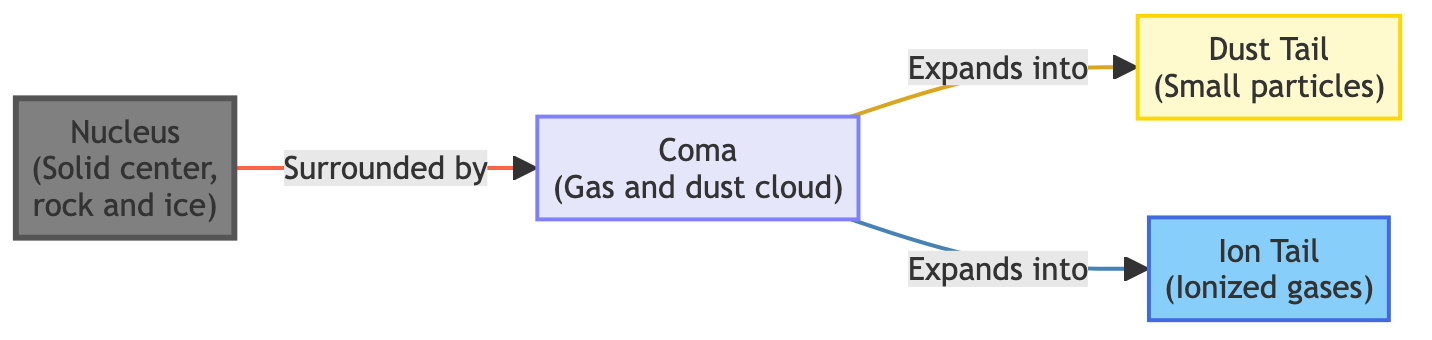What is the solid center of the comet called? The diagram identifies the solid center of the comet as the "Nucleus." This is explicitly labeled in the diagram, allowing for a direct answer.
Answer: Nucleus What surrounds the nucleus of the comet? The diagram indicates that the "Coma," which is a gas and dust cloud, surrounds the nucleus. This is depicted with a directional arrow indicating the relationship from the nucleus to the coma.
Answer: Coma How many main components are present in the diagram? The diagram includes four main components: the nucleus, the coma, the dust tail, and the ion tail. Counting these items provides the answer.
Answer: 4 Which tail consists of small particles? The diagram specifies that the "Dust Tail" consists of small particles. This is labeled distinctly within the diagram itself.
Answer: Dust Tail What type of gas makes up the ion tail of the comet? The diagram describes the "Ion Tail" as being composed of ionized gases, which is mentioned in the description under the ion tail component.
Answer: Ionized gases What expands into both the dust tail and ion tail? According to the diagram, the "Coma" expands into both the dust tail and the ion tail. The arrows connecting the coma to these components illustrate this expansion.
Answer: Coma What color represents the ion tail in the diagram? The diagram uses a specific color to represent the ion tail, which is a shade of light blue. This color is defined in the diagram through its class definition.
Answer: Light blue What is the primary material composing the nucleus? The diagram states that the nucleus consists of rock and ice. This information is included in the description associated with the nucleus node, simplifying the identification of materials.
Answer: Rock and ice What is the visual representation used to depict the coma? The diagram colors the coma in a light purple hue, which is outlined in the color coding provided in the diagram description. This visual cue allows for easy identification.
Answer: Light purple 